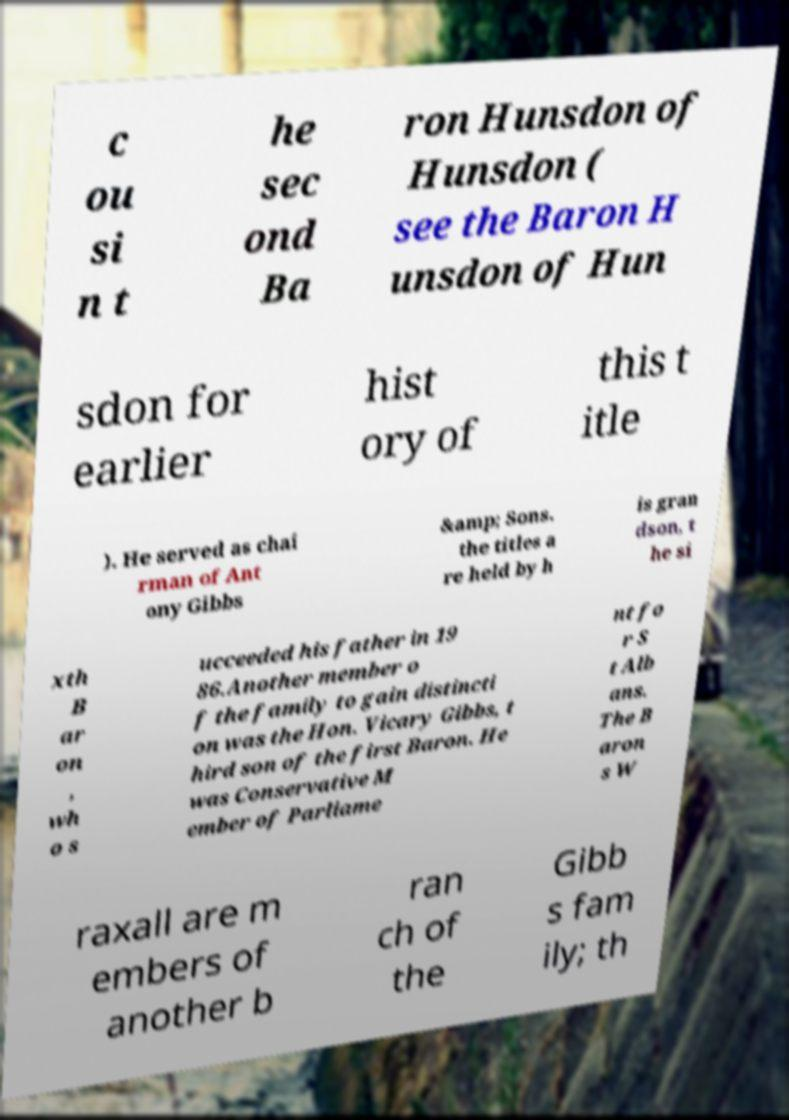Can you read and provide the text displayed in the image?This photo seems to have some interesting text. Can you extract and type it out for me? c ou si n t he sec ond Ba ron Hunsdon of Hunsdon ( see the Baron H unsdon of Hun sdon for earlier hist ory of this t itle ). He served as chai rman of Ant ony Gibbs &amp; Sons. the titles a re held by h is gran dson, t he si xth B ar on , wh o s ucceeded his father in 19 86.Another member o f the family to gain distincti on was the Hon. Vicary Gibbs, t hird son of the first Baron. He was Conservative M ember of Parliame nt fo r S t Alb ans. The B aron s W raxall are m embers of another b ran ch of the Gibb s fam ily; th 